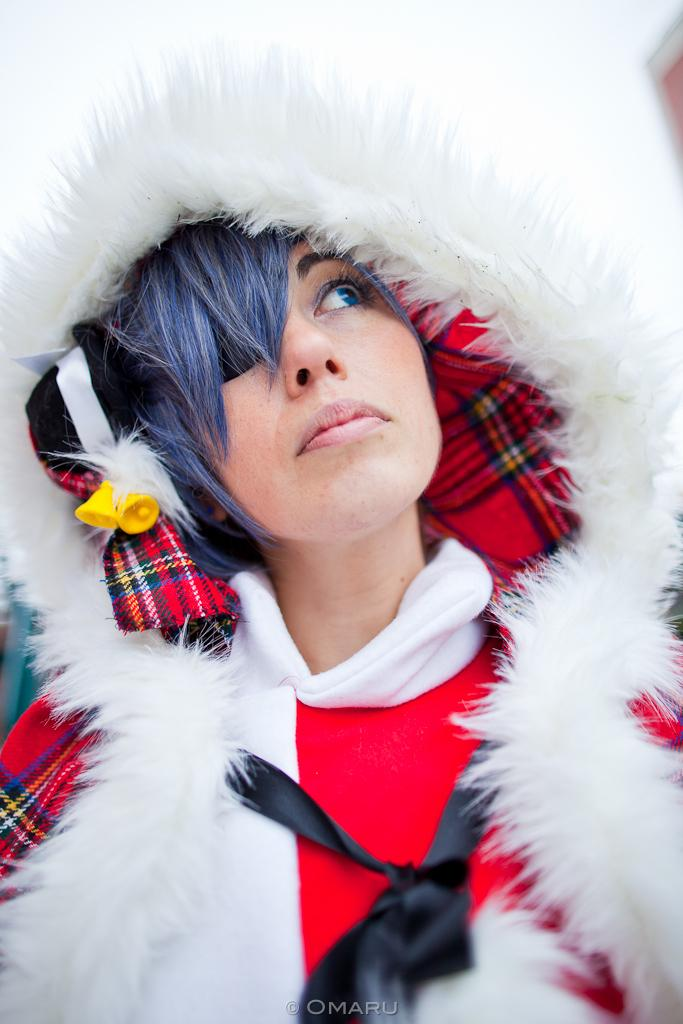Who is present in the image? There is a woman in the image. What can be found at the bottom of the image? There is some text at the bottom of the image. How many planes are flying through the mist in the image? There are no planes or mist present in the image. 